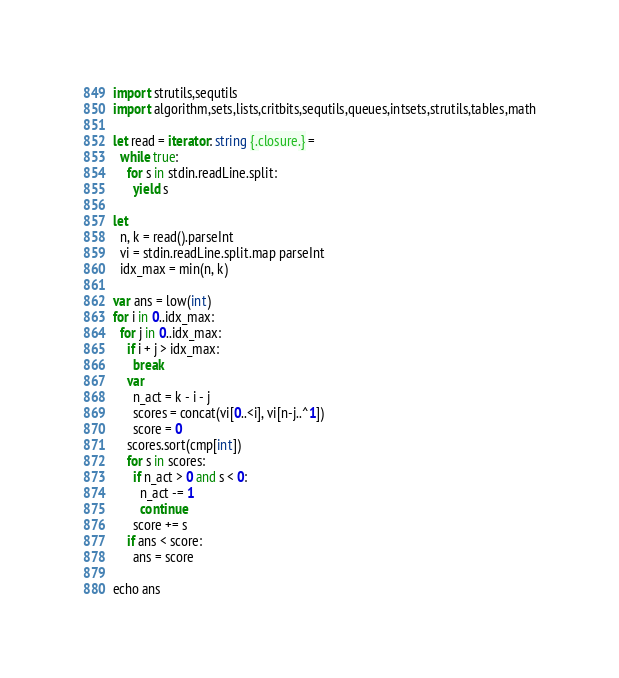Convert code to text. <code><loc_0><loc_0><loc_500><loc_500><_Nim_>import strutils,sequtils
import algorithm,sets,lists,critbits,sequtils,queues,intsets,strutils,tables,math

let read = iterator: string {.closure.} =
  while true:
    for s in stdin.readLine.split:
      yield s

let
  n, k = read().parseInt
  vi = stdin.readLine.split.map parseInt
  idx_max = min(n, k)

var ans = low(int)
for i in 0..idx_max:
  for j in 0..idx_max:
    if i + j > idx_max:
      break
    var
      n_act = k - i - j
      scores = concat(vi[0..<i], vi[n-j..^1])
      score = 0
    scores.sort(cmp[int])
    for s in scores:
      if n_act > 0 and s < 0:
        n_act -= 1
        continue
      score += s
    if ans < score:
      ans = score

echo ans
</code> 